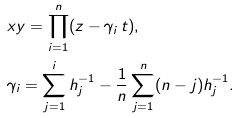<formula> <loc_0><loc_0><loc_500><loc_500>& x y = \prod _ { i = 1 } ^ { n } ( z - \gamma _ { i } \, t ) , \\ & \gamma _ { i } = \sum _ { j = 1 } ^ { i } h _ { j } ^ { - 1 } - \frac { 1 } { n } \sum _ { j = 1 } ^ { n } ( n - j ) h _ { j } ^ { - 1 } .</formula> 